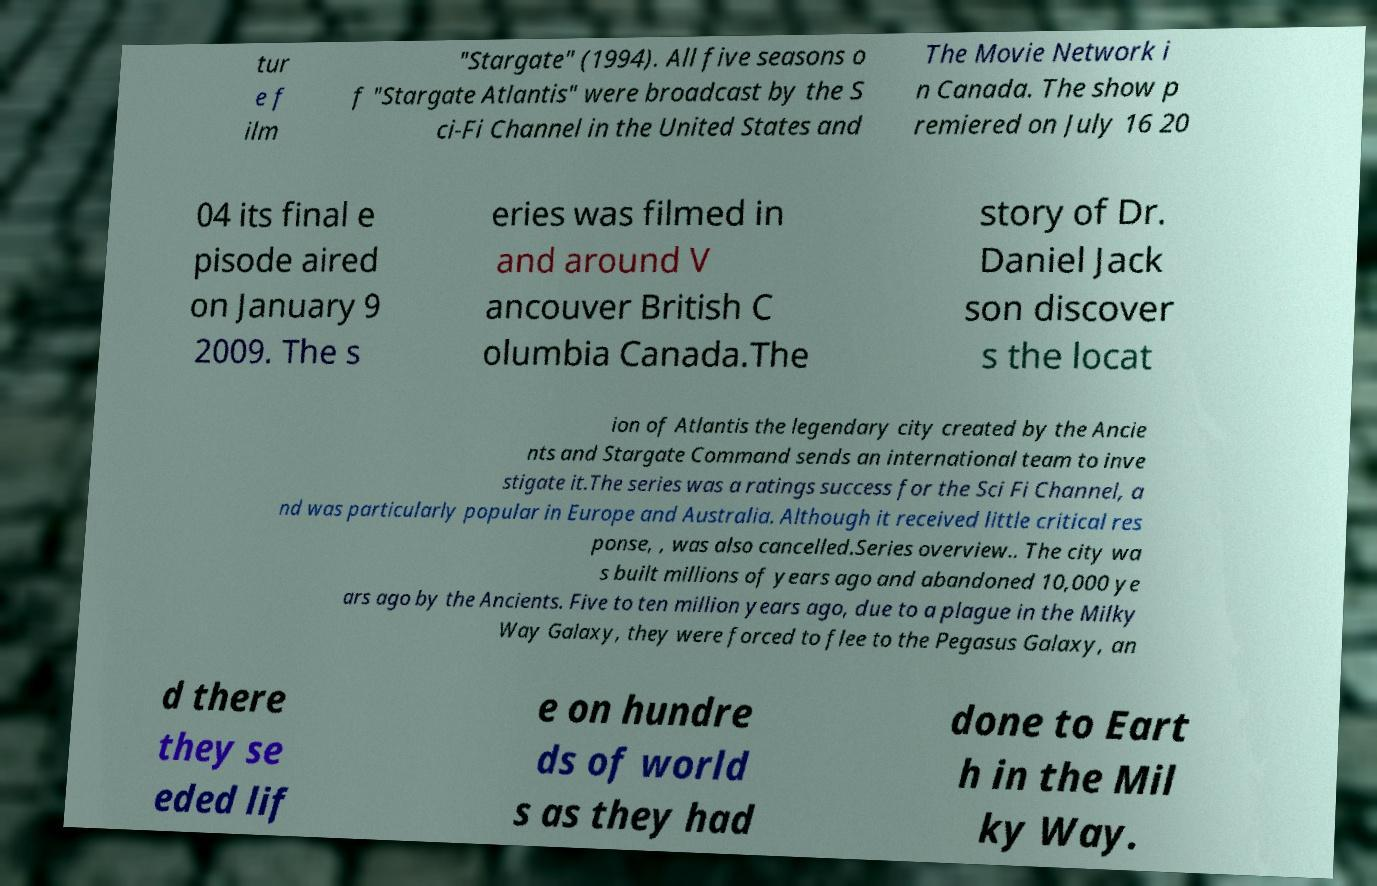Please identify and transcribe the text found in this image. tur e f ilm "Stargate" (1994). All five seasons o f "Stargate Atlantis" were broadcast by the S ci-Fi Channel in the United States and The Movie Network i n Canada. The show p remiered on July 16 20 04 its final e pisode aired on January 9 2009. The s eries was filmed in and around V ancouver British C olumbia Canada.The story of Dr. Daniel Jack son discover s the locat ion of Atlantis the legendary city created by the Ancie nts and Stargate Command sends an international team to inve stigate it.The series was a ratings success for the Sci Fi Channel, a nd was particularly popular in Europe and Australia. Although it received little critical res ponse, , was also cancelled.Series overview.. The city wa s built millions of years ago and abandoned 10,000 ye ars ago by the Ancients. Five to ten million years ago, due to a plague in the Milky Way Galaxy, they were forced to flee to the Pegasus Galaxy, an d there they se eded lif e on hundre ds of world s as they had done to Eart h in the Mil ky Way. 